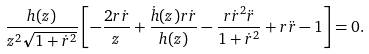Convert formula to latex. <formula><loc_0><loc_0><loc_500><loc_500>\frac { h ( z ) } { z ^ { 2 } \sqrt { 1 + \dot { r } ^ { 2 } } } \left [ - \frac { 2 r \dot { r } } { z } + \frac { \dot { h } ( z ) r \dot { r } } { h ( z ) } - \frac { r \dot { r } ^ { 2 } \ddot { r } } { 1 + \dot { r } ^ { 2 } } + r \ddot { r } - 1 \right ] = 0 .</formula> 